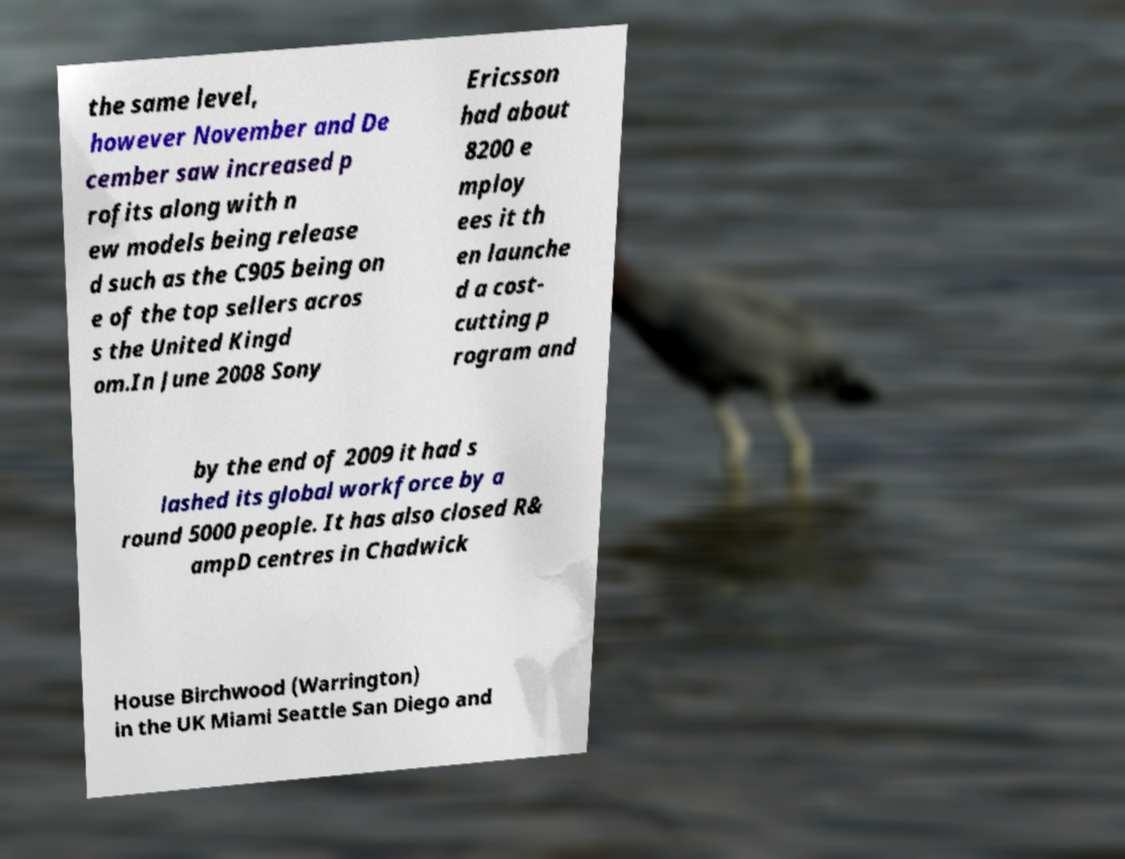There's text embedded in this image that I need extracted. Can you transcribe it verbatim? the same level, however November and De cember saw increased p rofits along with n ew models being release d such as the C905 being on e of the top sellers acros s the United Kingd om.In June 2008 Sony Ericsson had about 8200 e mploy ees it th en launche d a cost- cutting p rogram and by the end of 2009 it had s lashed its global workforce by a round 5000 people. It has also closed R& ampD centres in Chadwick House Birchwood (Warrington) in the UK Miami Seattle San Diego and 